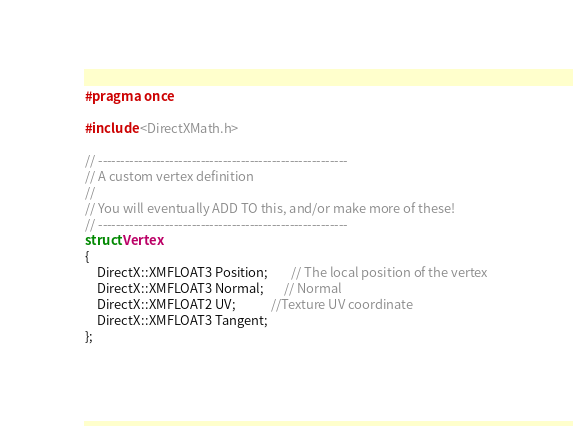<code> <loc_0><loc_0><loc_500><loc_500><_C_>#pragma once

#include <DirectXMath.h>

// --------------------------------------------------------
// A custom vertex definition
//
// You will eventually ADD TO this, and/or make more of these!
// --------------------------------------------------------
struct Vertex
{
	DirectX::XMFLOAT3 Position;	    // The local position of the vertex
	DirectX::XMFLOAT3 Normal;       // Normal
	DirectX::XMFLOAT2 UV;			//Texture UV coordinate
	DirectX::XMFLOAT3 Tangent;
};</code> 